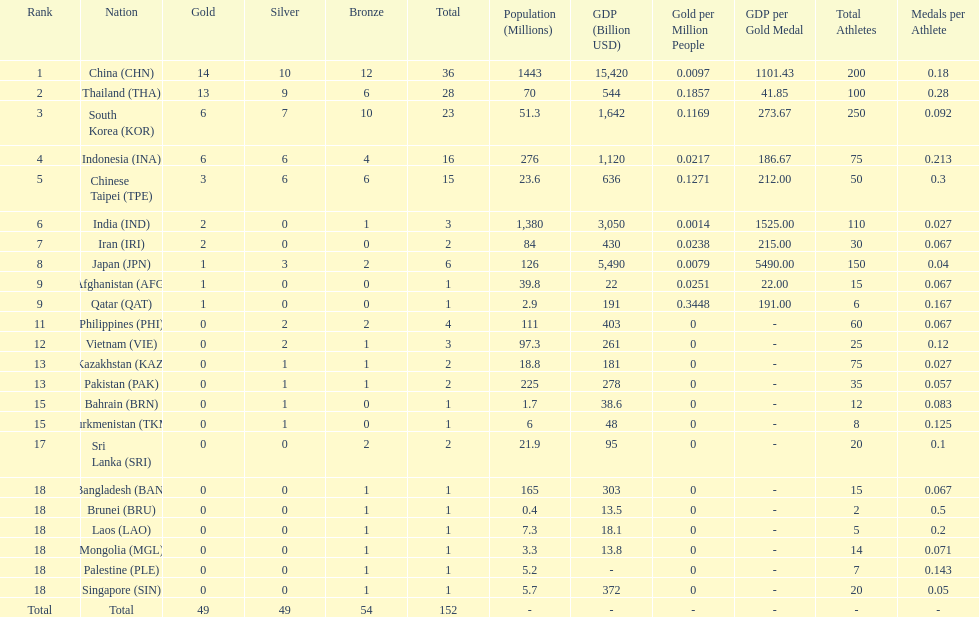How many more medals did india earn compared to pakistan? 1. 